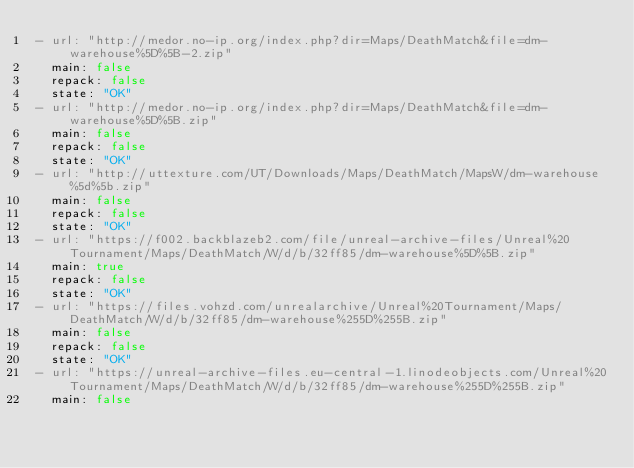Convert code to text. <code><loc_0><loc_0><loc_500><loc_500><_YAML_>- url: "http://medor.no-ip.org/index.php?dir=Maps/DeathMatch&file=dm-warehouse%5D%5B-2.zip"
  main: false
  repack: false
  state: "OK"
- url: "http://medor.no-ip.org/index.php?dir=Maps/DeathMatch&file=dm-warehouse%5D%5B.zip"
  main: false
  repack: false
  state: "OK"
- url: "http://uttexture.com/UT/Downloads/Maps/DeathMatch/MapsW/dm-warehouse%5d%5b.zip"
  main: false
  repack: false
  state: "OK"
- url: "https://f002.backblazeb2.com/file/unreal-archive-files/Unreal%20Tournament/Maps/DeathMatch/W/d/b/32ff85/dm-warehouse%5D%5B.zip"
  main: true
  repack: false
  state: "OK"
- url: "https://files.vohzd.com/unrealarchive/Unreal%20Tournament/Maps/DeathMatch/W/d/b/32ff85/dm-warehouse%255D%255B.zip"
  main: false
  repack: false
  state: "OK"
- url: "https://unreal-archive-files.eu-central-1.linodeobjects.com/Unreal%20Tournament/Maps/DeathMatch/W/d/b/32ff85/dm-warehouse%255D%255B.zip"
  main: false</code> 